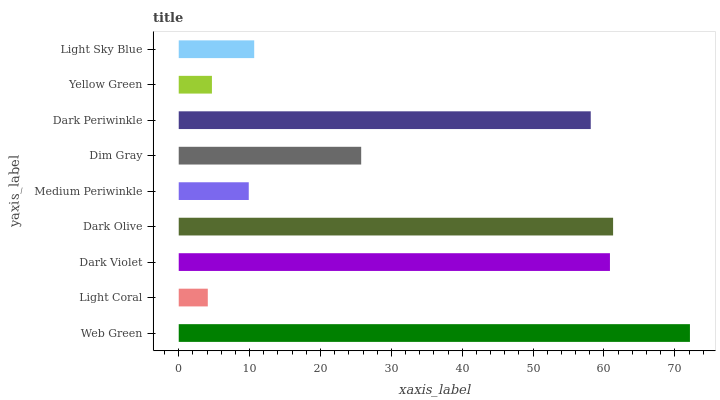Is Light Coral the minimum?
Answer yes or no. Yes. Is Web Green the maximum?
Answer yes or no. Yes. Is Dark Violet the minimum?
Answer yes or no. No. Is Dark Violet the maximum?
Answer yes or no. No. Is Dark Violet greater than Light Coral?
Answer yes or no. Yes. Is Light Coral less than Dark Violet?
Answer yes or no. Yes. Is Light Coral greater than Dark Violet?
Answer yes or no. No. Is Dark Violet less than Light Coral?
Answer yes or no. No. Is Dim Gray the high median?
Answer yes or no. Yes. Is Dim Gray the low median?
Answer yes or no. Yes. Is Dark Violet the high median?
Answer yes or no. No. Is Web Green the low median?
Answer yes or no. No. 